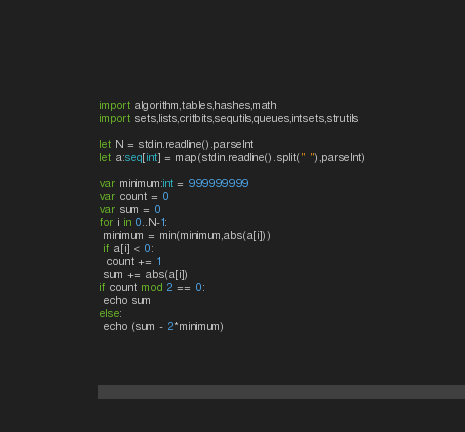Convert code to text. <code><loc_0><loc_0><loc_500><loc_500><_Nim_>import algorithm,tables,hashes,math
import sets,lists,critbits,sequtils,queues,intsets,strutils
 
let N = stdin.readline().parseInt
let a:seq[int] = map(stdin.readline().split(" "),parseInt)

var minimum:int = 999999999
var count = 0
var sum = 0
for i in 0..N-1:
 minimum = min(minimum,abs(a[i]))
 if a[i] < 0:
  count += 1
 sum += abs(a[i])
if count mod 2 == 0:
 echo sum
else:
 echo (sum - 2*minimum)</code> 